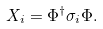Convert formula to latex. <formula><loc_0><loc_0><loc_500><loc_500>X _ { i } = \Phi ^ { \dagger } \sigma _ { i } \Phi .</formula> 